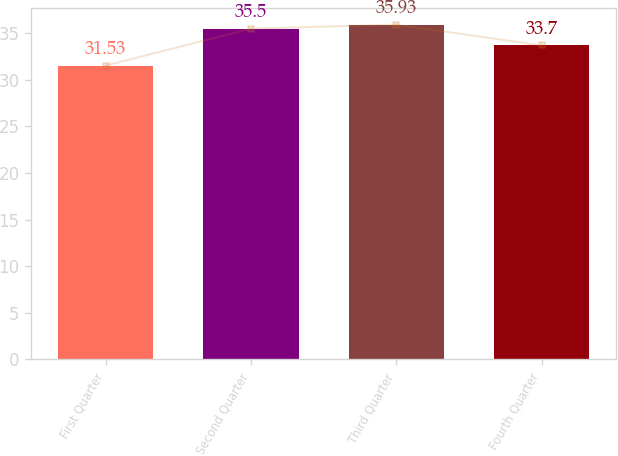<chart> <loc_0><loc_0><loc_500><loc_500><bar_chart><fcel>First Quarter<fcel>Second Quarter<fcel>Third Quarter<fcel>Fourth Quarter<nl><fcel>31.53<fcel>35.5<fcel>35.93<fcel>33.7<nl></chart> 